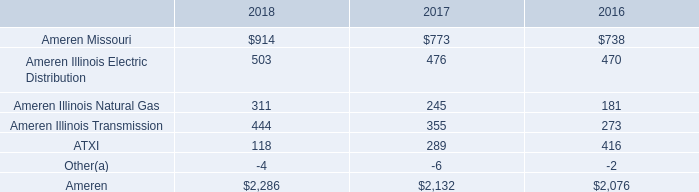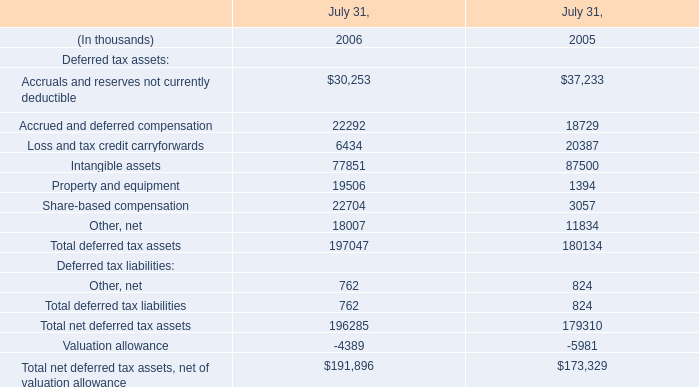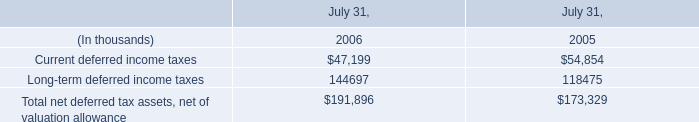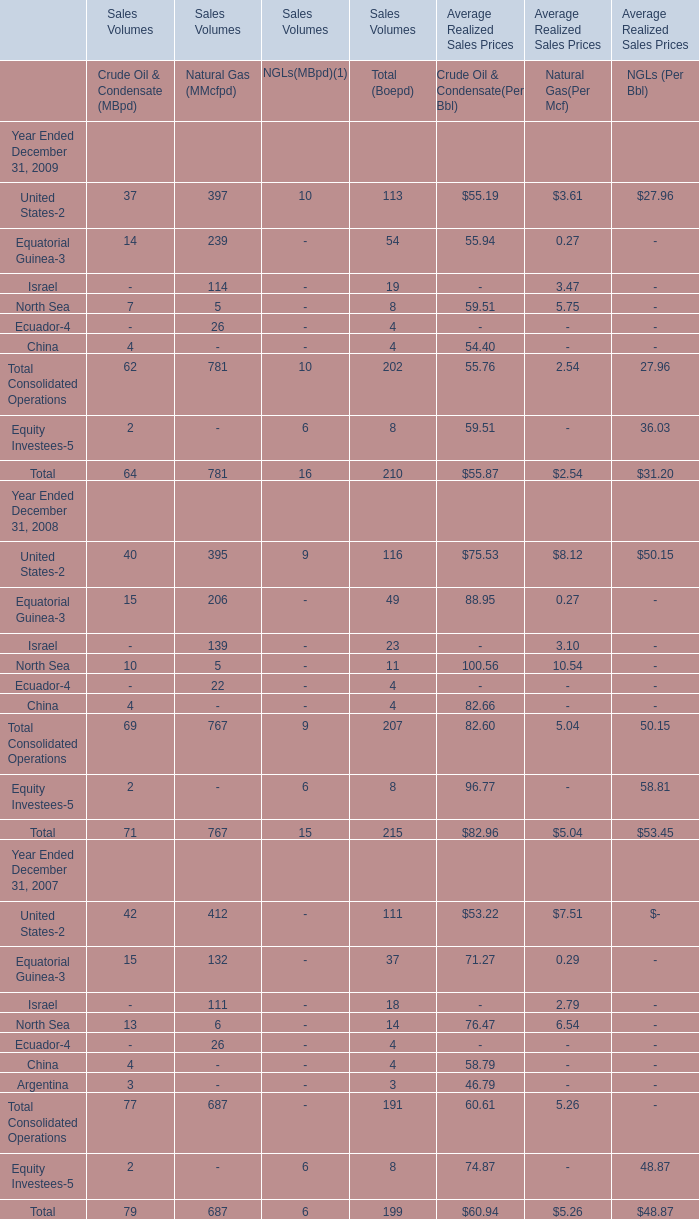What is the sum of Accrued and deferred compensation of July 31, 2005, and Current deferred income taxes of July 31, 2006 ? 
Computations: (18729.0 + 47199.0)
Answer: 65928.0. 